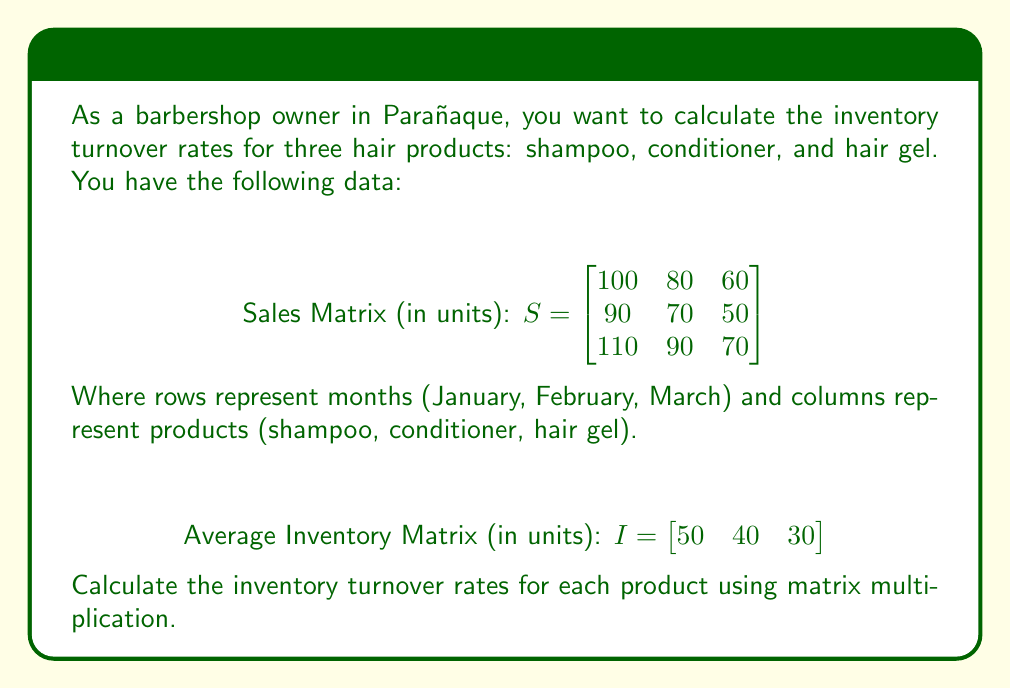Solve this math problem. To solve this problem, we'll follow these steps:

1) The inventory turnover rate is calculated by dividing total sales by average inventory.

2) First, we need to calculate the total sales for each product. We can do this by summing the columns of the Sales Matrix. Let's create a row vector for this:

   $$T = \begin{bmatrix} 300 & 240 & 180 \end{bmatrix}$$

3) Now, we need to divide each element of T by the corresponding element in I. We can achieve this using matrix multiplication with the inverse of I.

4) To get the inverse of I, we create a diagonal matrix from its elements and invert it:

   $$I^{-1} = \begin{bmatrix}
   1/50 & 0 & 0 \\
   0 & 1/40 & 0 \\
   0 & 0 & 1/30
   \end{bmatrix}$$

5) Now we can calculate the inventory turnover rates (R) using matrix multiplication:

   $$R = T \times I^{-1}$$

6) Performing the multiplication:

   $$R = \begin{bmatrix} 300 & 240 & 180 \end{bmatrix} \times 
   \begin{bmatrix}
   1/50 & 0 & 0 \\
   0 & 1/40 & 0 \\
   0 & 0 & 1/30
   \end{bmatrix}$$

   $$R = \begin{bmatrix} 300 \times 1/50 & 240 \times 1/40 & 180 \times 1/30 \end{bmatrix}$$

   $$R = \begin{bmatrix} 6 & 6 & 6 \end{bmatrix}$$

Therefore, the inventory turnover rates for shampoo, conditioner, and hair gel are all 6 times per period.
Answer: $R = \begin{bmatrix} 6 & 6 & 6 \end{bmatrix}$ 